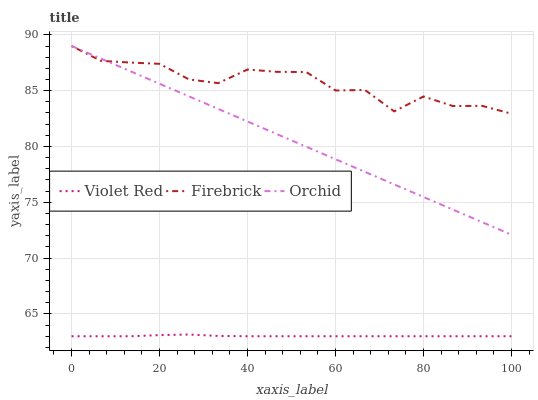Does Violet Red have the minimum area under the curve?
Answer yes or no. Yes. Does Firebrick have the maximum area under the curve?
Answer yes or no. Yes. Does Orchid have the minimum area under the curve?
Answer yes or no. No. Does Orchid have the maximum area under the curve?
Answer yes or no. No. Is Orchid the smoothest?
Answer yes or no. Yes. Is Firebrick the roughest?
Answer yes or no. Yes. Is Firebrick the smoothest?
Answer yes or no. No. Is Orchid the roughest?
Answer yes or no. No. Does Violet Red have the lowest value?
Answer yes or no. Yes. Does Orchid have the lowest value?
Answer yes or no. No. Does Orchid have the highest value?
Answer yes or no. Yes. Is Violet Red less than Orchid?
Answer yes or no. Yes. Is Firebrick greater than Violet Red?
Answer yes or no. Yes. Does Firebrick intersect Orchid?
Answer yes or no. Yes. Is Firebrick less than Orchid?
Answer yes or no. No. Is Firebrick greater than Orchid?
Answer yes or no. No. Does Violet Red intersect Orchid?
Answer yes or no. No. 